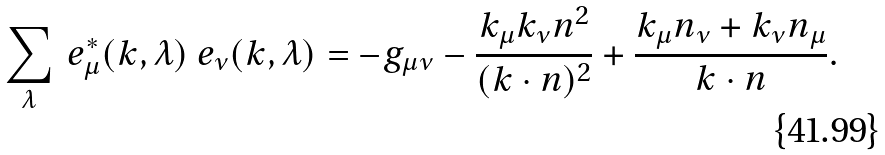<formula> <loc_0><loc_0><loc_500><loc_500>\sum _ { \lambda } \ e ^ { * } _ { \mu } ( k , \lambda ) \ e _ { \nu } ( k , \lambda ) = - g _ { \mu \nu } - \frac { k _ { \mu } k _ { \nu } n ^ { 2 } } { ( k \cdot n ) ^ { 2 } } + \frac { k _ { \mu } n _ { \nu } + k _ { \nu } n _ { \mu } } { k \cdot n } .</formula> 